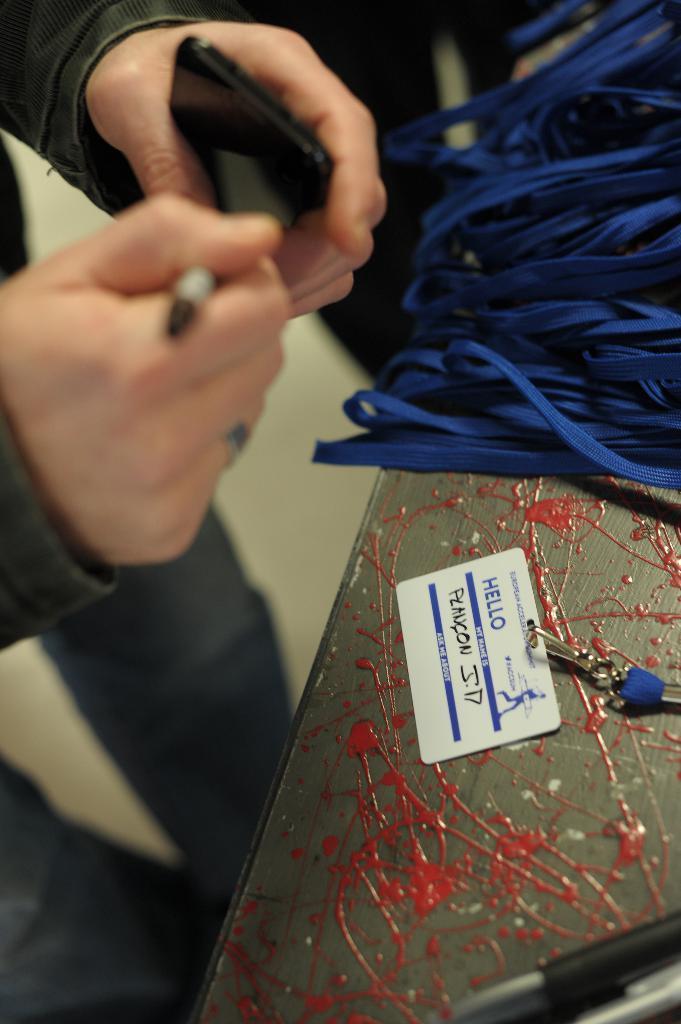Could you give a brief overview of what you see in this image? In this image we can see some man standing and holding a mobile phone. We can also see some blue color ropes on the painted table. There is also a card with the text on the table. 